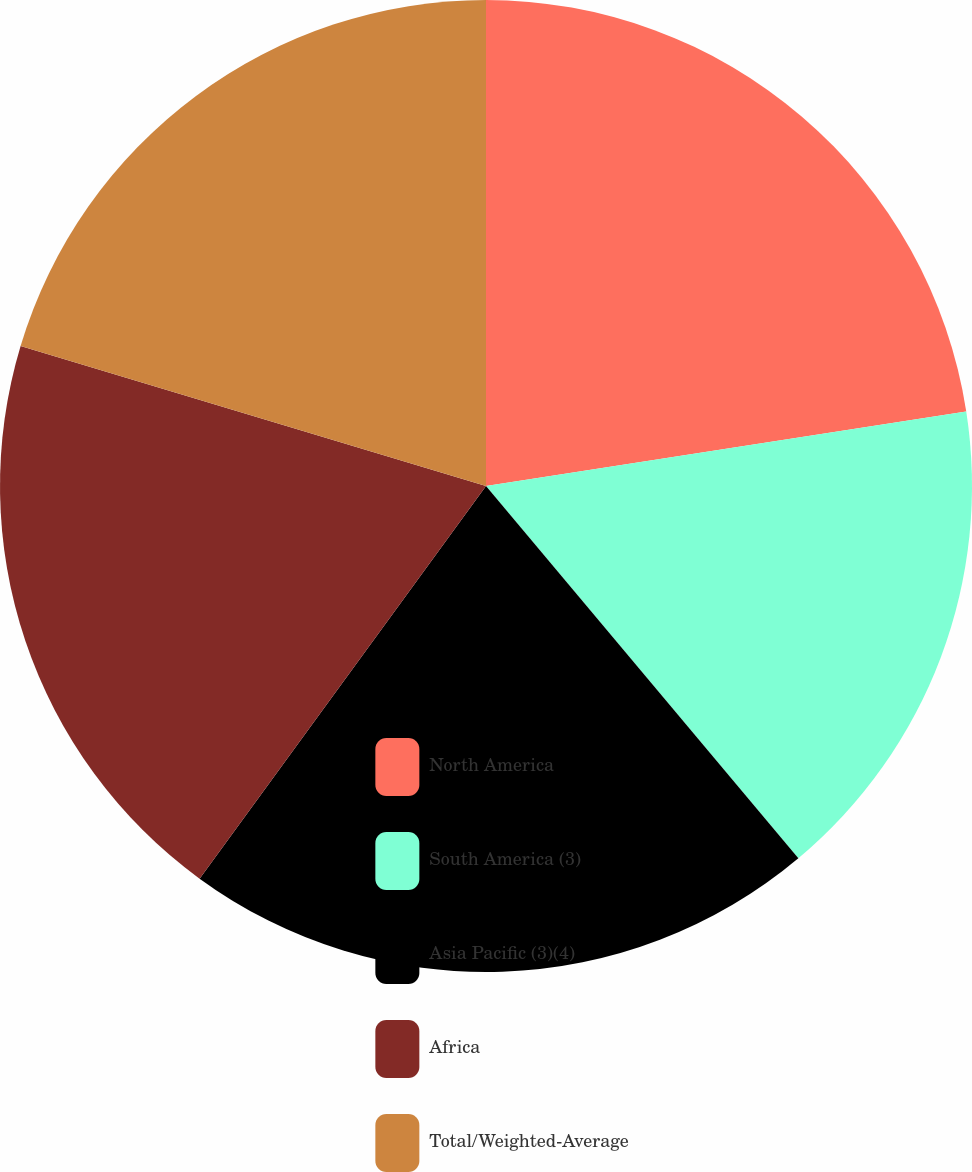Convert chart. <chart><loc_0><loc_0><loc_500><loc_500><pie_chart><fcel>North America<fcel>South America (3)<fcel>Asia Pacific (3)(4)<fcel>Africa<fcel>Total/Weighted-Average<nl><fcel>22.55%<fcel>16.34%<fcel>21.14%<fcel>19.62%<fcel>20.35%<nl></chart> 